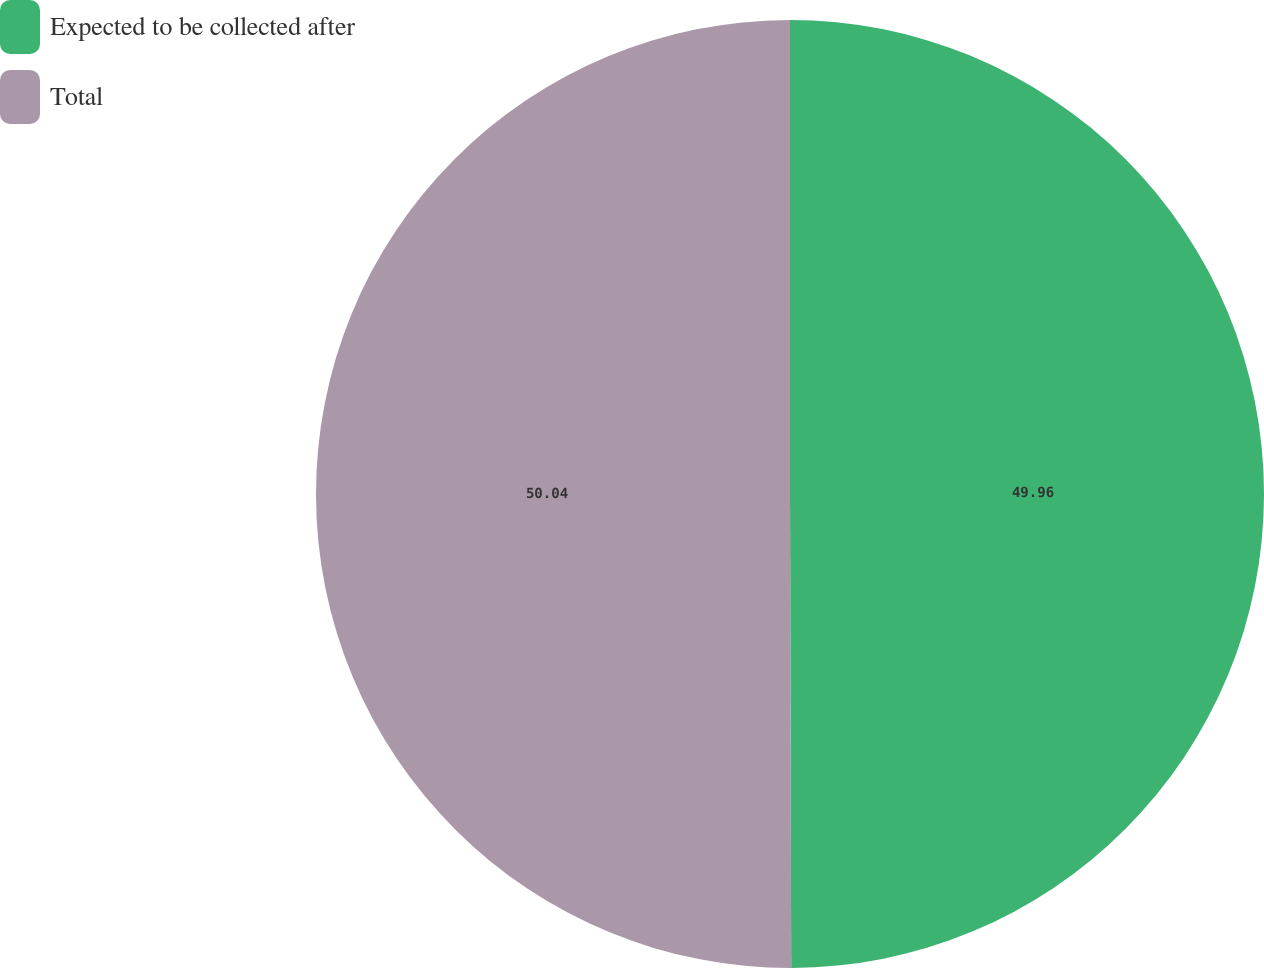<chart> <loc_0><loc_0><loc_500><loc_500><pie_chart><fcel>Expected to be collected after<fcel>Total<nl><fcel>49.96%<fcel>50.04%<nl></chart> 